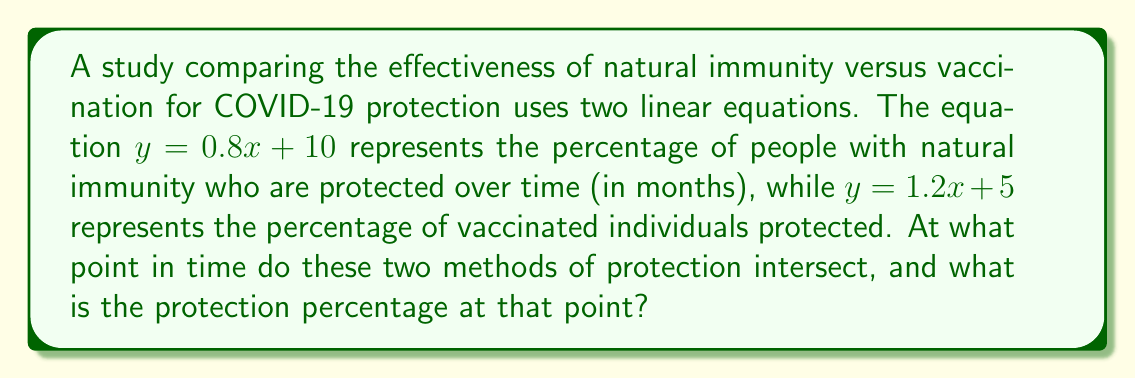Solve this math problem. To find the intersection of these two health-related data sets, we need to solve the system of equations:

$$\begin{cases}
y = 0.8x + 10 \quad \text{(natural immunity)}\\
y = 1.2x + 5 \quad \text{(vaccination)}
\end{cases}$$

1) At the intersection point, both equations are equal. So we can set them equal to each other:

   $0.8x + 10 = 1.2x + 5$

2) Subtract $0.8x$ from both sides:

   $10 = 0.4x + 5$

3) Subtract 5 from both sides:

   $5 = 0.4x$

4) Divide both sides by 0.4:

   $\frac{5}{0.4} = x$
   $12.5 = x$

5) Now that we know $x$, we can substitute it into either of the original equations to find $y$. Let's use the natural immunity equation:

   $y = 0.8(12.5) + 10$
   $y = 10 + 10 = 20$

Therefore, the two methods of protection intersect at 12.5 months, with a protection percentage of 20%.
Answer: (12.5, 20) 